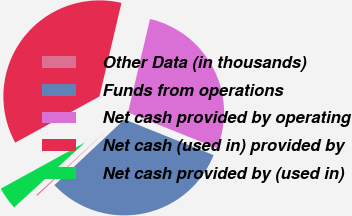Convert chart. <chart><loc_0><loc_0><loc_500><loc_500><pie_chart><fcel>Other Data (in thousands)<fcel>Funds from operations<fcel>Net cash provided by operating<fcel>Net cash (used in) provided by<fcel>Net cash provided by (used in)<nl><fcel>0.19%<fcel>31.92%<fcel>27.4%<fcel>36.67%<fcel>3.83%<nl></chart> 